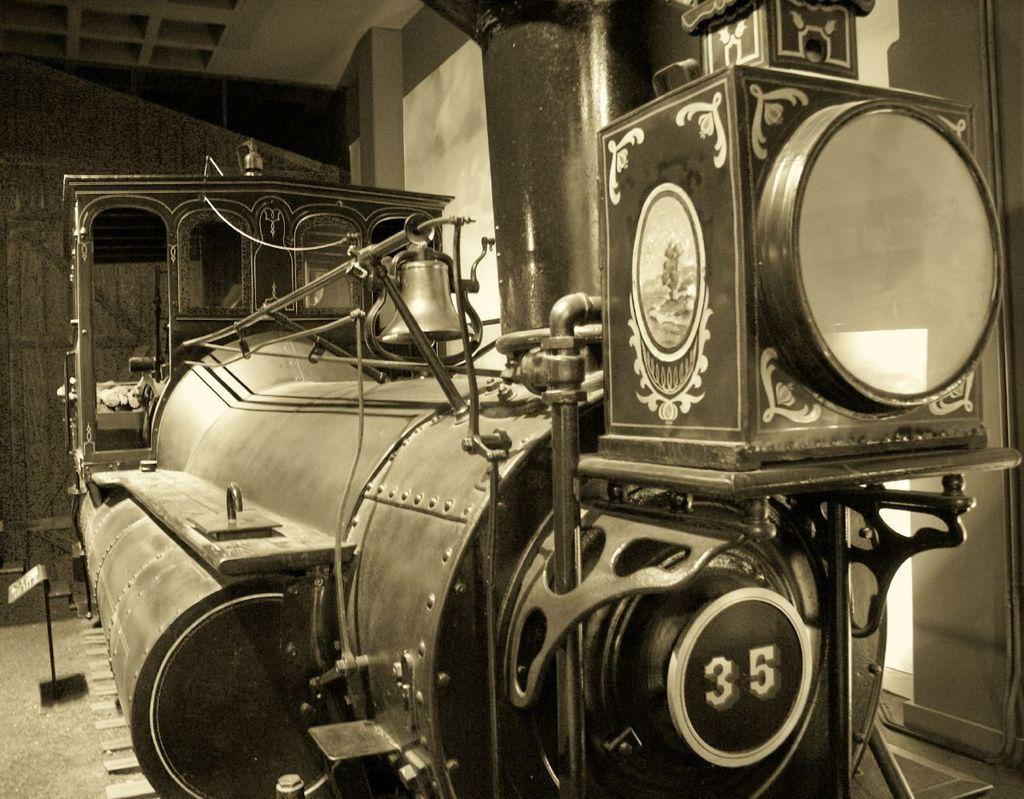What is the main subject of the picture? The main subject of the picture is a train engine. Are there any specific features or objects related to the train engine? Yes, there is a bell in the picture. What can be seen in the background of the picture? There is a wall in the background of the picture. What is the color scheme of the picture? The picture is black and white. What type of nose can be seen on the train engine in the image? There is no nose present on the train engine in the image, as train engines do not have noses. What territory does the train engine cover in the image? The image does not provide information about the train engine's territory, as it only shows the train engine and a bell. 